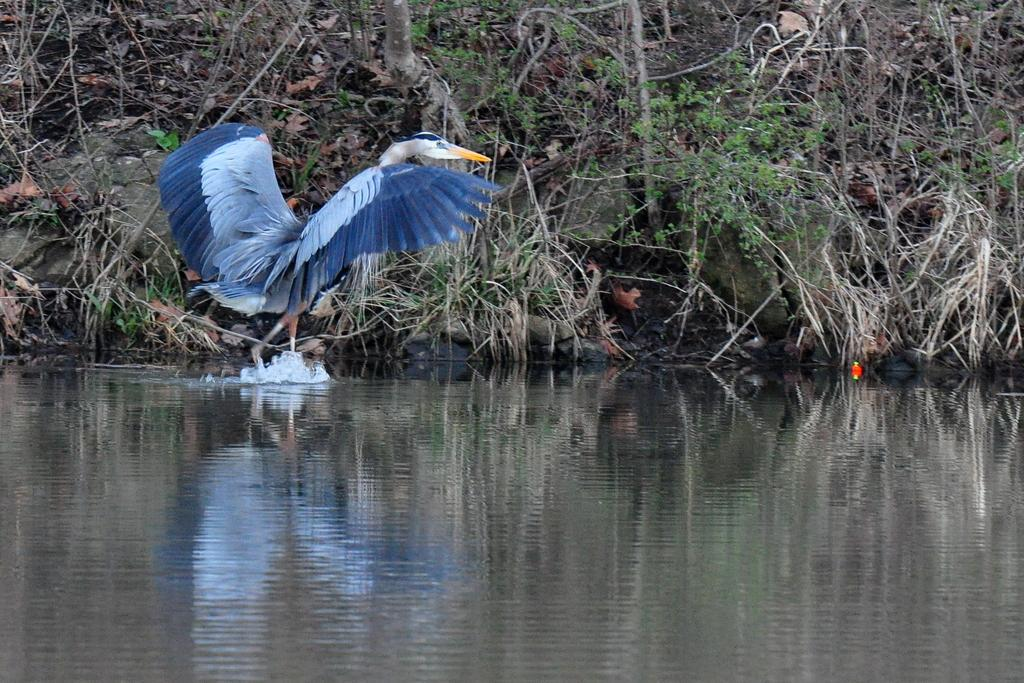What is visible at the bottom of the image? There is water visible at the bottom of the image. What type of animal can be seen in the image? There is a bird in the image. Where are the bird's legs located in relation to the water? The bird's legs are in the water. What can be seen in the background of the image? There are plants and grass on the ground in the background of the image. What type of patch is visible on the bird's wing in the image? There is no patch visible on the bird's wing in the image. 